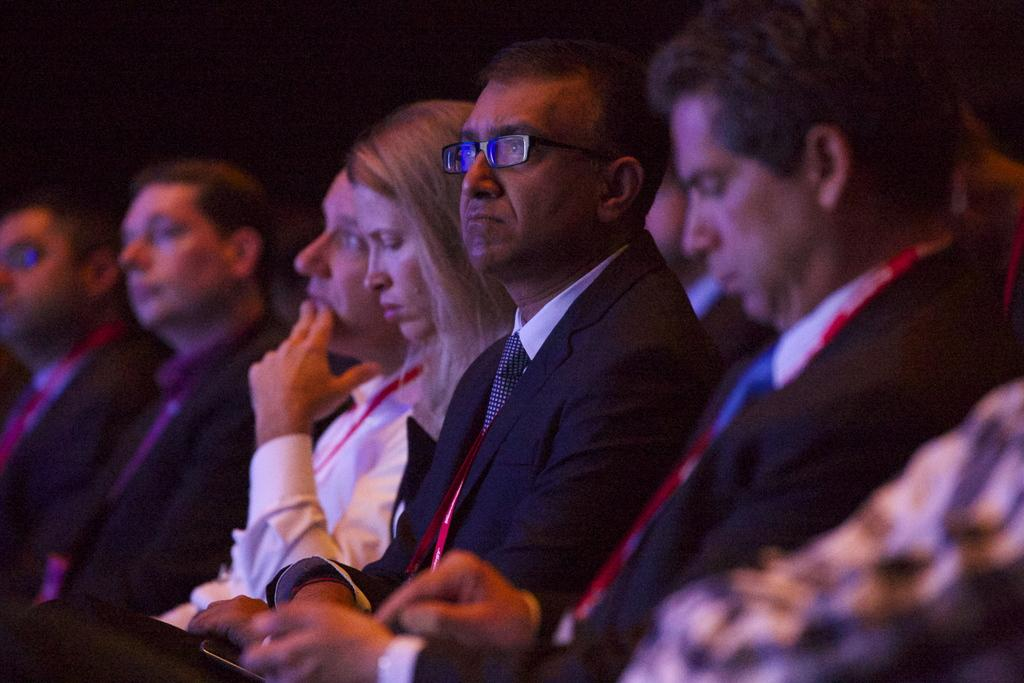How many people are in the image? There is a group of persons in the image. Can you describe the clothing of one of the men in the image? One man is wearing a coat. What accessory is the man wearing in the image? The man is wearing spectacles. How many eggs are visible in the image? There are no eggs present in the image. What shape does the man's coat form in the image? The shape of the man's coat cannot be determined from the image alone. 